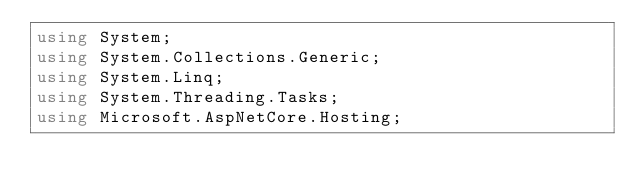<code> <loc_0><loc_0><loc_500><loc_500><_C#_>using System;
using System.Collections.Generic;
using System.Linq;
using System.Threading.Tasks;
using Microsoft.AspNetCore.Hosting;</code> 